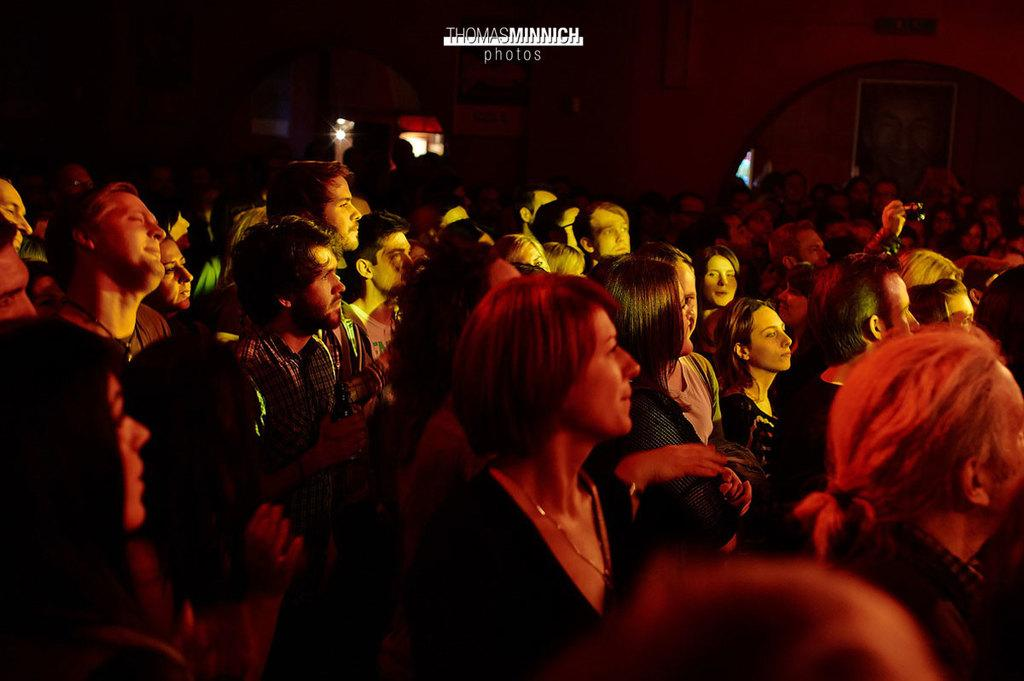How many people are in the image? There is a group of persons in the image. What can be seen behind the persons? There is a light visible behind the persons, and there is also a wall behind them. What is on the wall behind the persons? There is a poster of a person on the wall. What type of hope can be seen in the image? There is no reference to hope in the image, so it cannot be determined what type of hope might be present. 